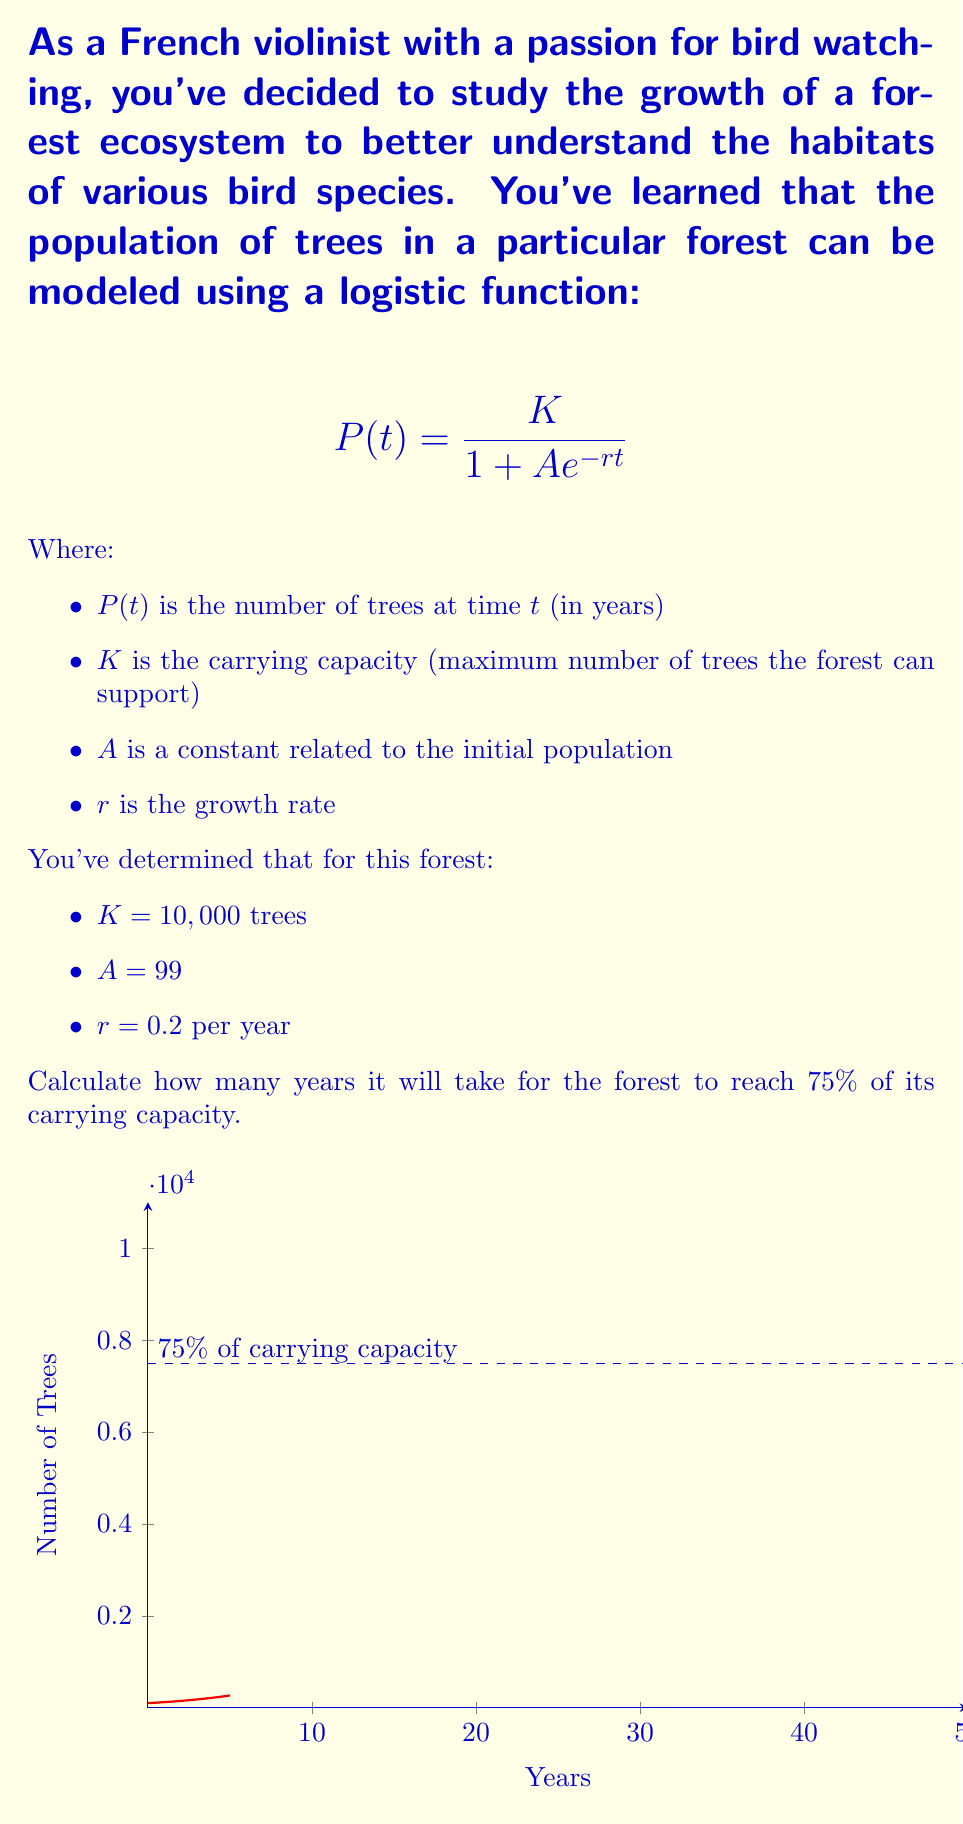Help me with this question. Let's approach this step-by-step:

1) We want to find $t$ when $P(t)$ is 75% of $K$. So, we need to solve:

   $$0.75K = \frac{K}{1 + Ae^{-rt}}$$

2) Substituting the known values:

   $$7500 = \frac{10000}{1 + 99e^{-0.2t}}$$

3) Simplify the right side:

   $$7500(1 + 99e^{-0.2t}) = 10000$$

4) Expand:

   $$7500 + 742500e^{-0.2t} = 10000$$

5) Subtract 7500 from both sides:

   $$742500e^{-0.2t} = 2500$$

6) Divide both sides by 742500:

   $$e^{-0.2t} = \frac{1}{297}$$

7) Take the natural log of both sides:

   $$-0.2t = \ln(\frac{1}{297}) = -\ln(297)$$

8) Divide both sides by -0.2:

   $$t = \frac{\ln(297)}{0.2}$$

9) Calculate the result:

   $$t \approx 28.47 \text{ years}$$
Answer: $28.47$ years 